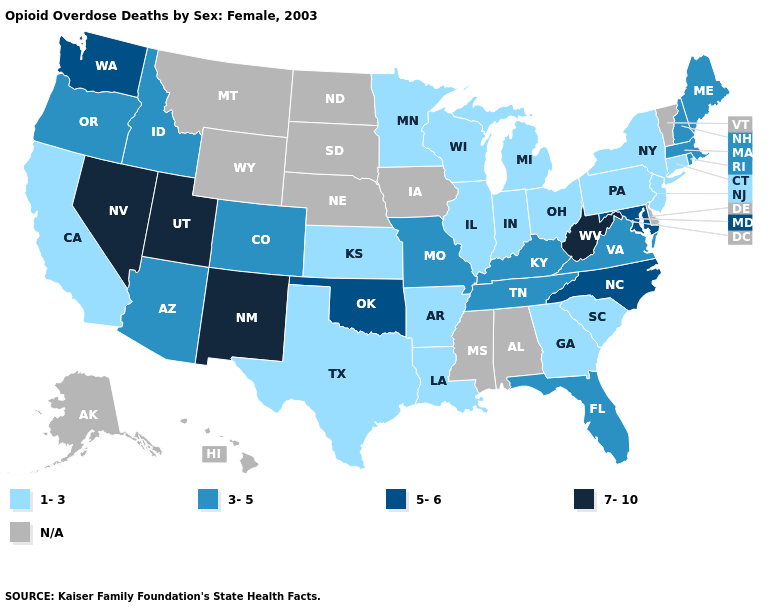Which states hav the highest value in the Northeast?
Be succinct. Maine, Massachusetts, New Hampshire, Rhode Island. What is the highest value in states that border Rhode Island?
Write a very short answer. 3-5. Name the states that have a value in the range 1-3?
Quick response, please. Arkansas, California, Connecticut, Georgia, Illinois, Indiana, Kansas, Louisiana, Michigan, Minnesota, New Jersey, New York, Ohio, Pennsylvania, South Carolina, Texas, Wisconsin. Which states have the lowest value in the West?
Write a very short answer. California. Name the states that have a value in the range 5-6?
Keep it brief. Maryland, North Carolina, Oklahoma, Washington. What is the value of West Virginia?
Short answer required. 7-10. Is the legend a continuous bar?
Keep it brief. No. What is the lowest value in the USA?
Concise answer only. 1-3. Name the states that have a value in the range 7-10?
Keep it brief. Nevada, New Mexico, Utah, West Virginia. Name the states that have a value in the range 3-5?
Write a very short answer. Arizona, Colorado, Florida, Idaho, Kentucky, Maine, Massachusetts, Missouri, New Hampshire, Oregon, Rhode Island, Tennessee, Virginia. Which states have the lowest value in the USA?
Give a very brief answer. Arkansas, California, Connecticut, Georgia, Illinois, Indiana, Kansas, Louisiana, Michigan, Minnesota, New Jersey, New York, Ohio, Pennsylvania, South Carolina, Texas, Wisconsin. Name the states that have a value in the range N/A?
Be succinct. Alabama, Alaska, Delaware, Hawaii, Iowa, Mississippi, Montana, Nebraska, North Dakota, South Dakota, Vermont, Wyoming. What is the highest value in the USA?
Quick response, please. 7-10. What is the value of Alabama?
Write a very short answer. N/A. 